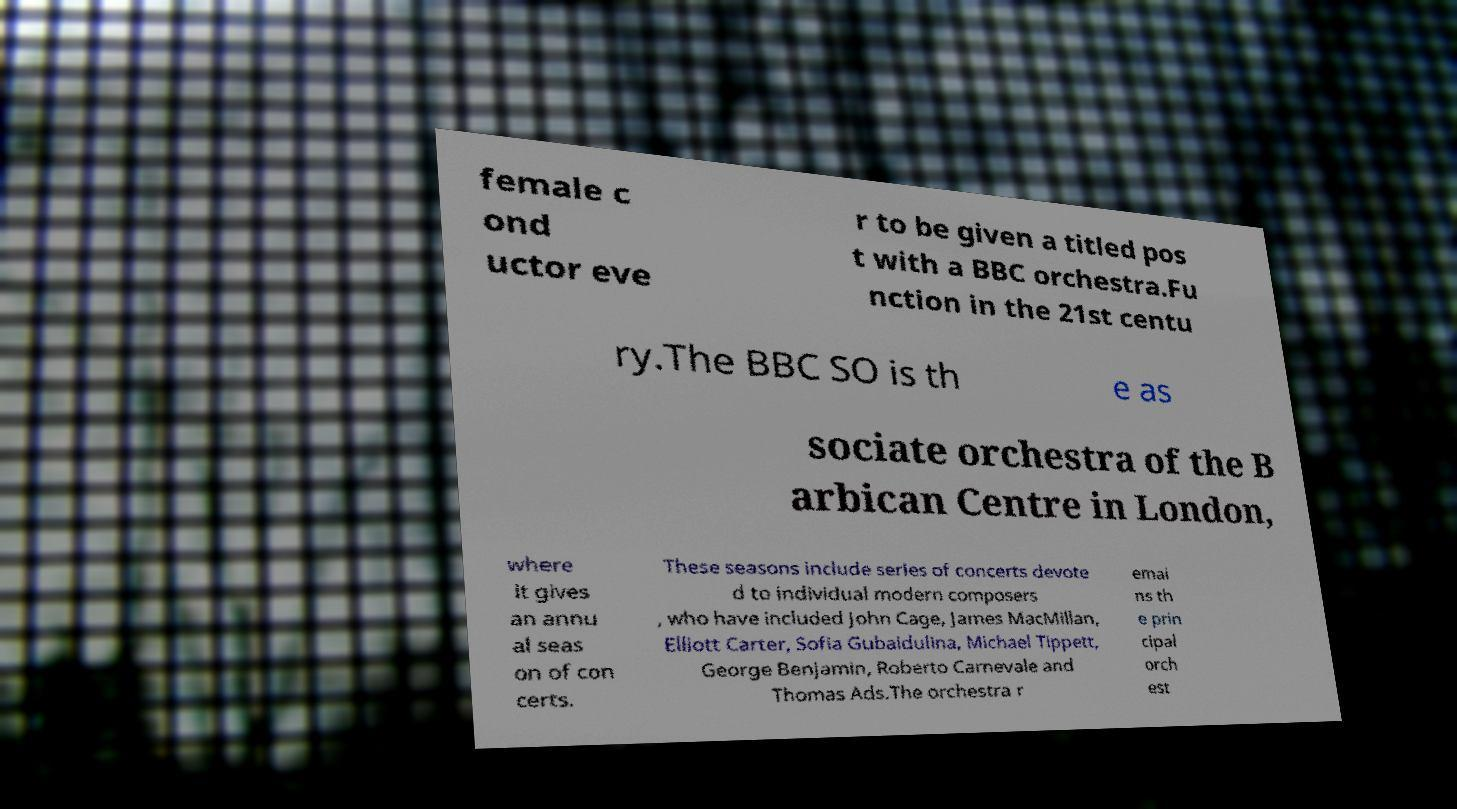What messages or text are displayed in this image? I need them in a readable, typed format. female c ond uctor eve r to be given a titled pos t with a BBC orchestra.Fu nction in the 21st centu ry.The BBC SO is th e as sociate orchestra of the B arbican Centre in London, where it gives an annu al seas on of con certs. These seasons include series of concerts devote d to individual modern composers , who have included John Cage, James MacMillan, Elliott Carter, Sofia Gubaidulina, Michael Tippett, George Benjamin, Roberto Carnevale and Thomas Ads.The orchestra r emai ns th e prin cipal orch est 